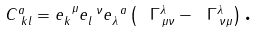Convert formula to latex. <formula><loc_0><loc_0><loc_500><loc_500>C _ { \, \text {\ } k l } ^ { a } = e _ { k } ^ { \text { \ } \mu } e _ { l } ^ { \text { \ } \nu } e _ { \lambda } ^ { \text { \ } a } \left ( \ \Gamma _ { \, \mu \nu } ^ { \lambda } - \ \Gamma _ { \, \nu \mu } ^ { \lambda } \right ) \text {.}</formula> 